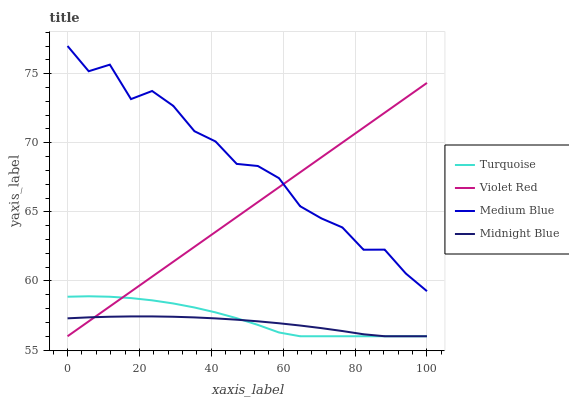Does Midnight Blue have the minimum area under the curve?
Answer yes or no. Yes. Does Medium Blue have the maximum area under the curve?
Answer yes or no. Yes. Does Violet Red have the minimum area under the curve?
Answer yes or no. No. Does Violet Red have the maximum area under the curve?
Answer yes or no. No. Is Violet Red the smoothest?
Answer yes or no. Yes. Is Medium Blue the roughest?
Answer yes or no. Yes. Is Medium Blue the smoothest?
Answer yes or no. No. Is Violet Red the roughest?
Answer yes or no. No. Does Turquoise have the lowest value?
Answer yes or no. Yes. Does Medium Blue have the lowest value?
Answer yes or no. No. Does Medium Blue have the highest value?
Answer yes or no. Yes. Does Violet Red have the highest value?
Answer yes or no. No. Is Midnight Blue less than Medium Blue?
Answer yes or no. Yes. Is Medium Blue greater than Midnight Blue?
Answer yes or no. Yes. Does Violet Red intersect Turquoise?
Answer yes or no. Yes. Is Violet Red less than Turquoise?
Answer yes or no. No. Is Violet Red greater than Turquoise?
Answer yes or no. No. Does Midnight Blue intersect Medium Blue?
Answer yes or no. No. 